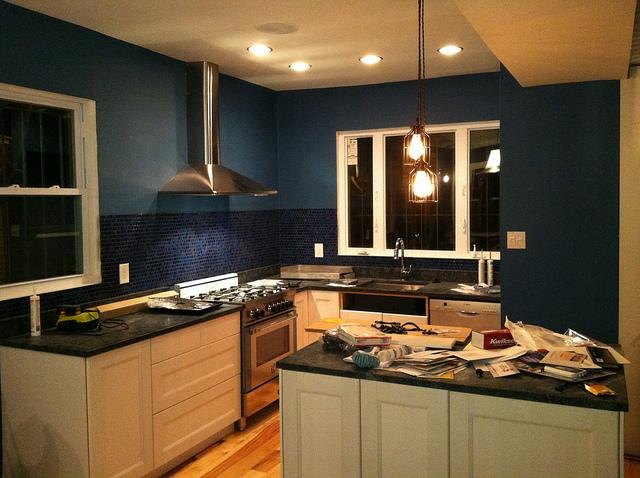What kind of backsplash has been attached to the wall?

Choices:
A) natural stone
B) metal
C) stainless steel
D) glass glass 